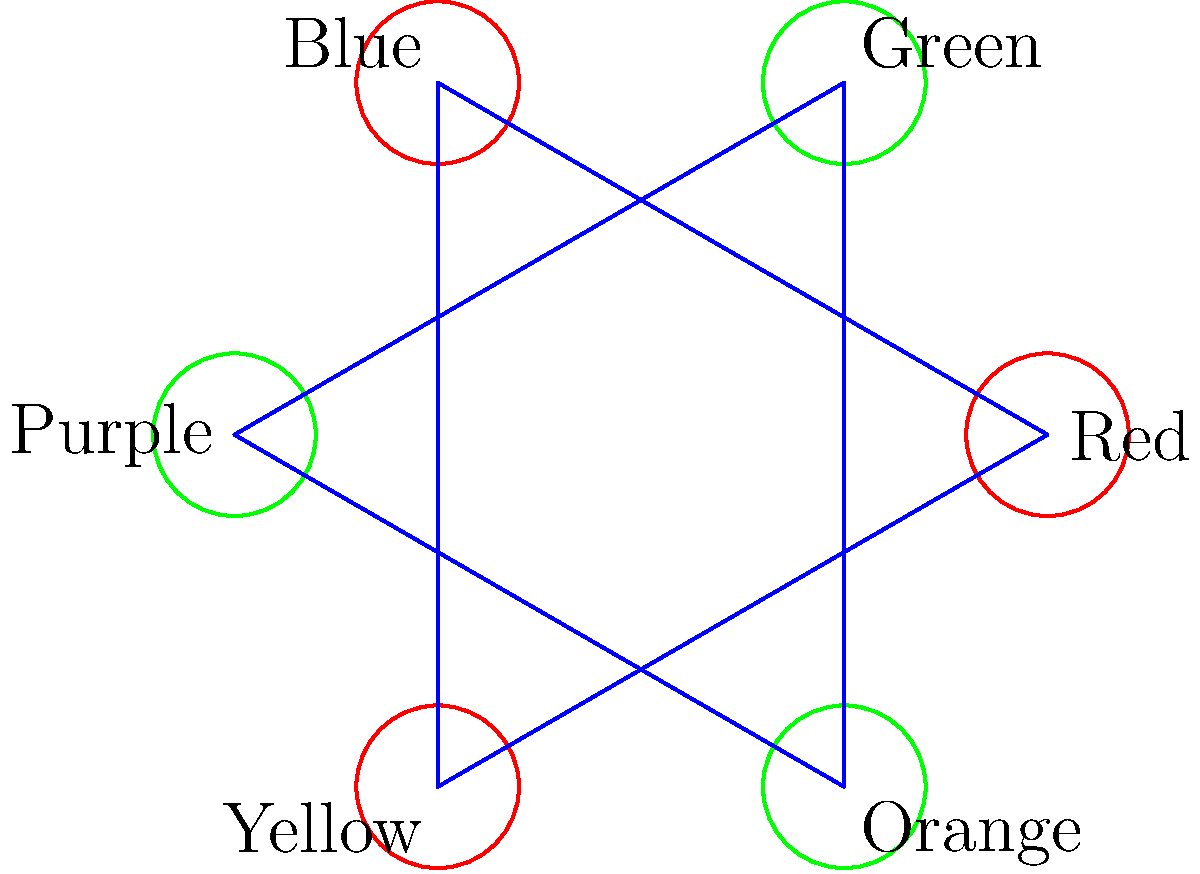In the color wheel graph shown, primary colors are represented by red nodes and secondary colors by green nodes. If we consider this graph as a representation of color mixing, what is the minimum number of edges that need to be removed to disconnect all primary colors from each other? To approach this question, let's follow these steps:

1. Identify the primary colors: Red, Blue, and Yellow (represented by red nodes).

2. Observe the connections between primary colors:
   - There is a direct edge between each pair of primary colors, forming a triangle.

3. Count the number of edges connecting primary colors:
   - Red to Blue
   - Blue to Yellow
   - Yellow to Red
   Total: 3 edges

4. Consider the impact of removing edges:
   - Removing any single edge will still leave two primary colors connected.
   - Removing any two edges will disconnect one primary color from the other two.
   - Removing all three edges will completely disconnect all primary colors from each other.

5. Determine the minimum number of edges to remove:
   - We need to remove at least 2 edges to ensure that no two primary colors are directly connected.

Therefore, the minimum number of edges that need to be removed to disconnect all primary colors from each other is 2.
Answer: 2 edges 